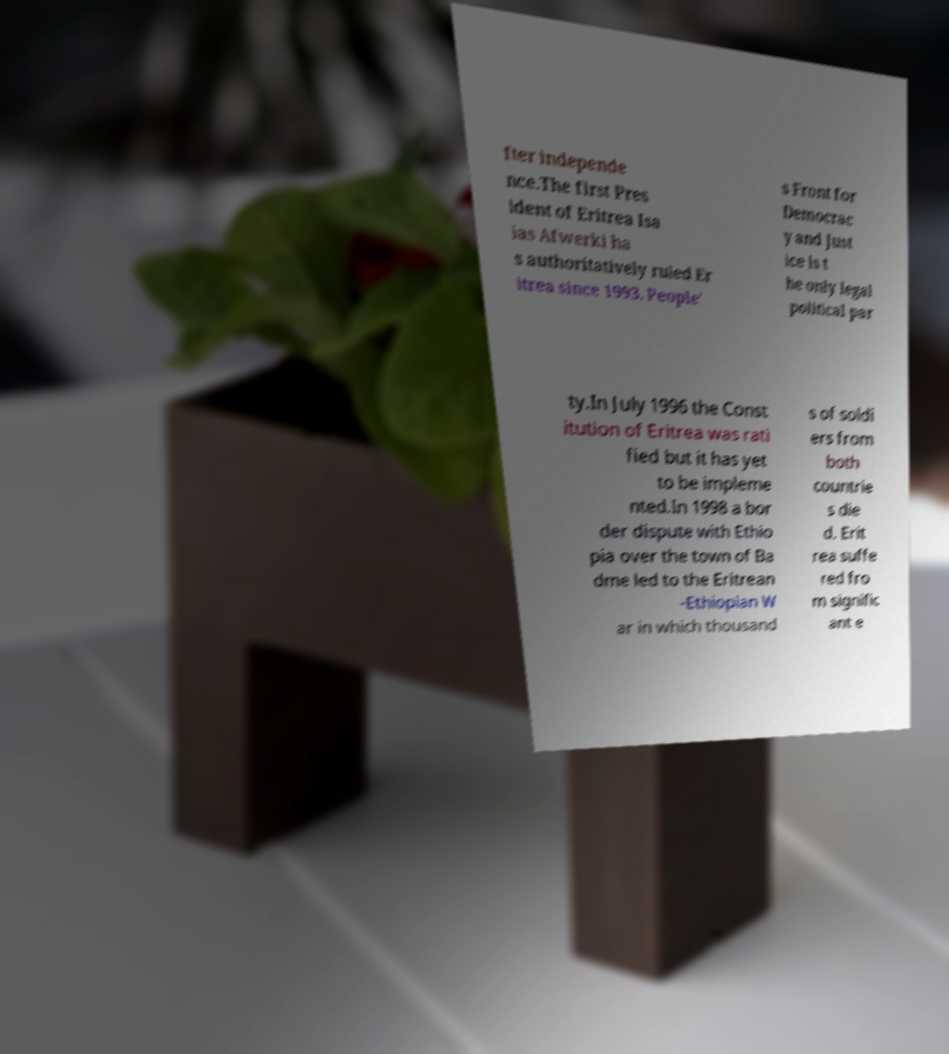I need the written content from this picture converted into text. Can you do that? fter independe nce.The first Pres ident of Eritrea Isa ias Afwerki ha s authoritatively ruled Er itrea since 1993. People' s Front for Democrac y and Just ice is t he only legal political par ty.In July 1996 the Const itution of Eritrea was rati fied but it has yet to be impleme nted.In 1998 a bor der dispute with Ethio pia over the town of Ba dme led to the Eritrean -Ethiopian W ar in which thousand s of soldi ers from both countrie s die d. Erit rea suffe red fro m signific ant e 